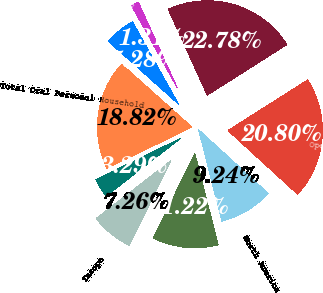Convert chart to OTSL. <chart><loc_0><loc_0><loc_500><loc_500><pie_chart><fcel>Operating Profit<fcel>North America<fcel>Latin America<fcel>Europe<fcel>Asia/Africa<fcel>Total Oral Personal Household<fcel>Total Pet Nutrition<fcel>Total Corporate<fcel>Total Operating Profit<nl><fcel>20.8%<fcel>9.24%<fcel>11.22%<fcel>7.26%<fcel>3.29%<fcel>18.82%<fcel>5.28%<fcel>1.31%<fcel>22.78%<nl></chart> 